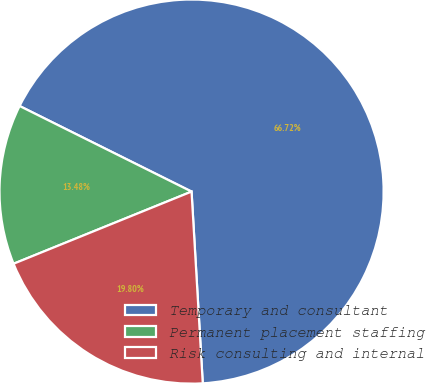<chart> <loc_0><loc_0><loc_500><loc_500><pie_chart><fcel>Temporary and consultant<fcel>Permanent placement staffing<fcel>Risk consulting and internal<nl><fcel>66.72%<fcel>13.48%<fcel>19.8%<nl></chart> 